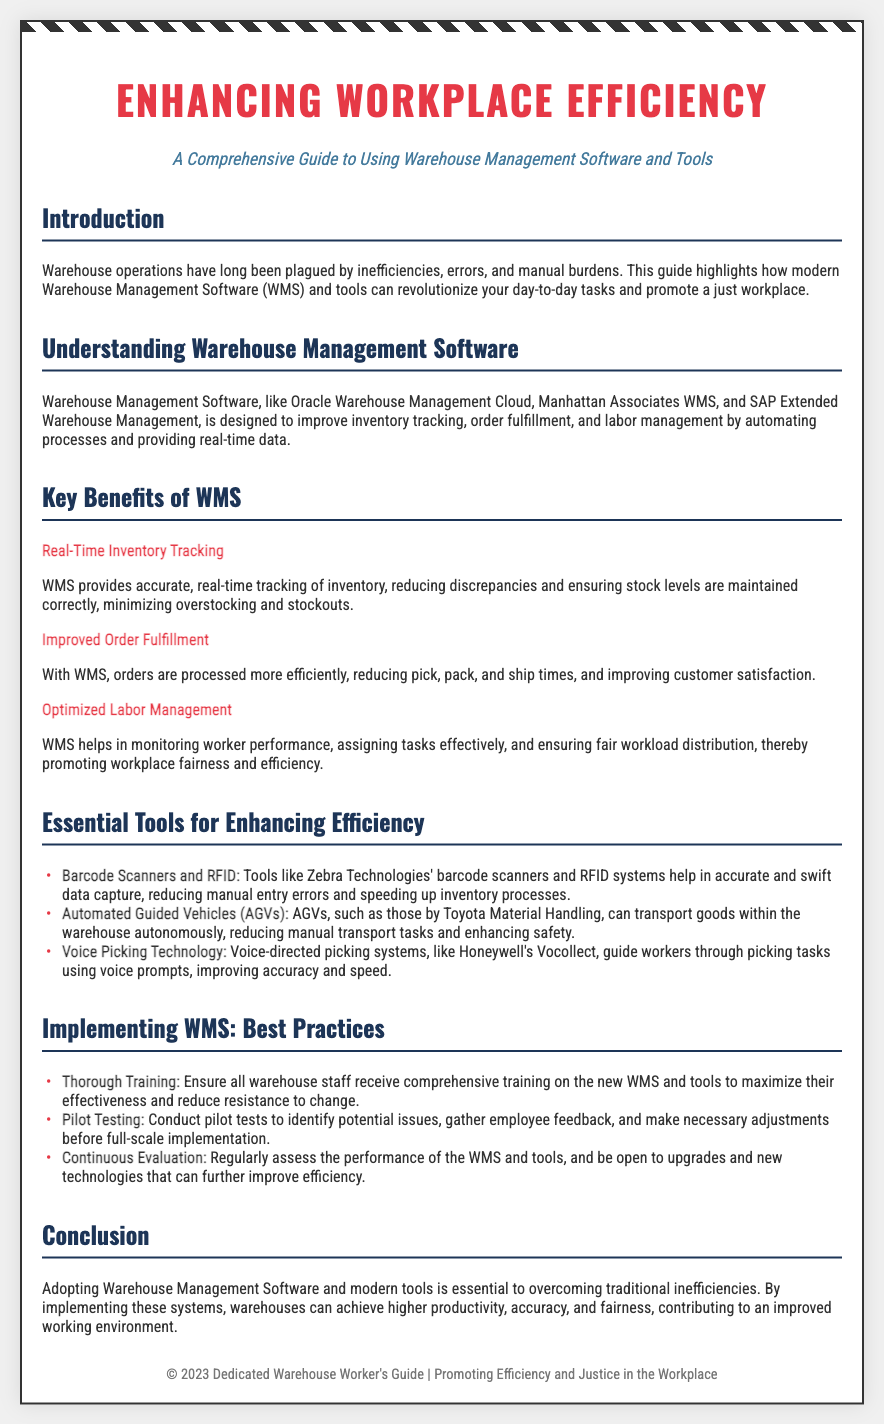What is the title of the guide? The title of the guide is prominently displayed at the beginning of the document.
Answer: Enhancing Workplace Efficiency What is the primary focus of the document? The focus of the document is explained in the description section directly below the title.
Answer: Warehouse Management Software and Tools Which software is mentioned as an example of WMS? The document lists several examples of Warehouse Management Software in one of its sections.
Answer: Oracle Warehouse Management Cloud What are the key benefits of WMS mentioned? The document outlines several key benefits of WMS in a dedicated section.
Answer: Real-Time Inventory Tracking, Improved Order Fulfillment, Optimized Labor Management What is one essential tool for enhancing efficiency? The document provides a list of essential tools in a specified section.
Answer: Barcode Scanners and RFID What is a recommended practice for implementing WMS? The document suggests best practices under a specific section, one of which addresses training.
Answer: Thorough Training How does the document describe the impact of WMS on the workplace? The conclusion provides insights into the overall effect of adopting WMS on the working environment.
Answer: Improved working environment What is the intended outcome of using Warehouse Management Software? The conclusion summarizes the goals of implementing WMS and modern tools.
Answer: Higher productivity, accuracy, and fairness 